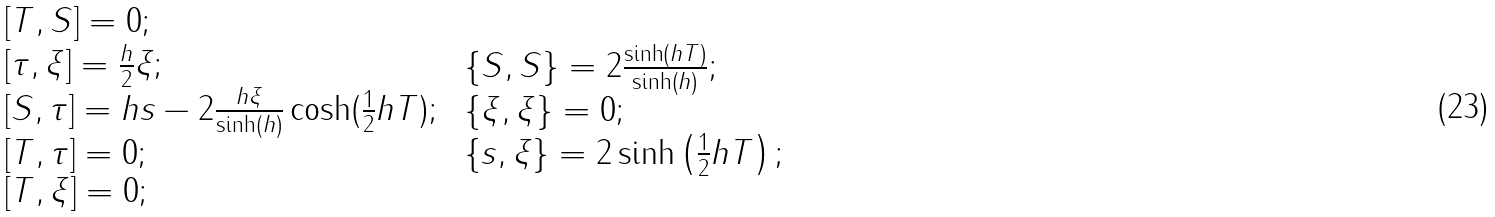Convert formula to latex. <formula><loc_0><loc_0><loc_500><loc_500>\begin{array} { l } \, \left [ T , S \right ] = 0 ; \\ \, \left [ \tau , \xi \right ] = \frac { h } { 2 } \xi ; \\ \, \left [ S , \tau \right ] = h s - 2 \frac { h \xi } { \sinh \left ( h \right ) } \cosh ( \frac { 1 } { 2 } h T ) ; \\ \, \left [ T , \tau \right ] = 0 ; \\ \, \left [ T , \xi \right ] = 0 ; \end{array} \, \begin{array} { l } \, \left \{ S , S \right \} = 2 \frac { \sinh \left ( h T \right ) } { \sinh \left ( h \right ) } ; \\ \, \left \{ \xi , \xi \right \} = 0 ; \\ \, \left \{ s , \xi \right \} = 2 \sinh \left ( \frac { 1 } { 2 } h T \right ) ; \end{array}</formula> 